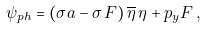<formula> <loc_0><loc_0><loc_500><loc_500>\psi _ { p h } = ( \sigma a - \sigma \, F ) \, \overline { \eta } \, \eta + p _ { y } F \, ,</formula> 